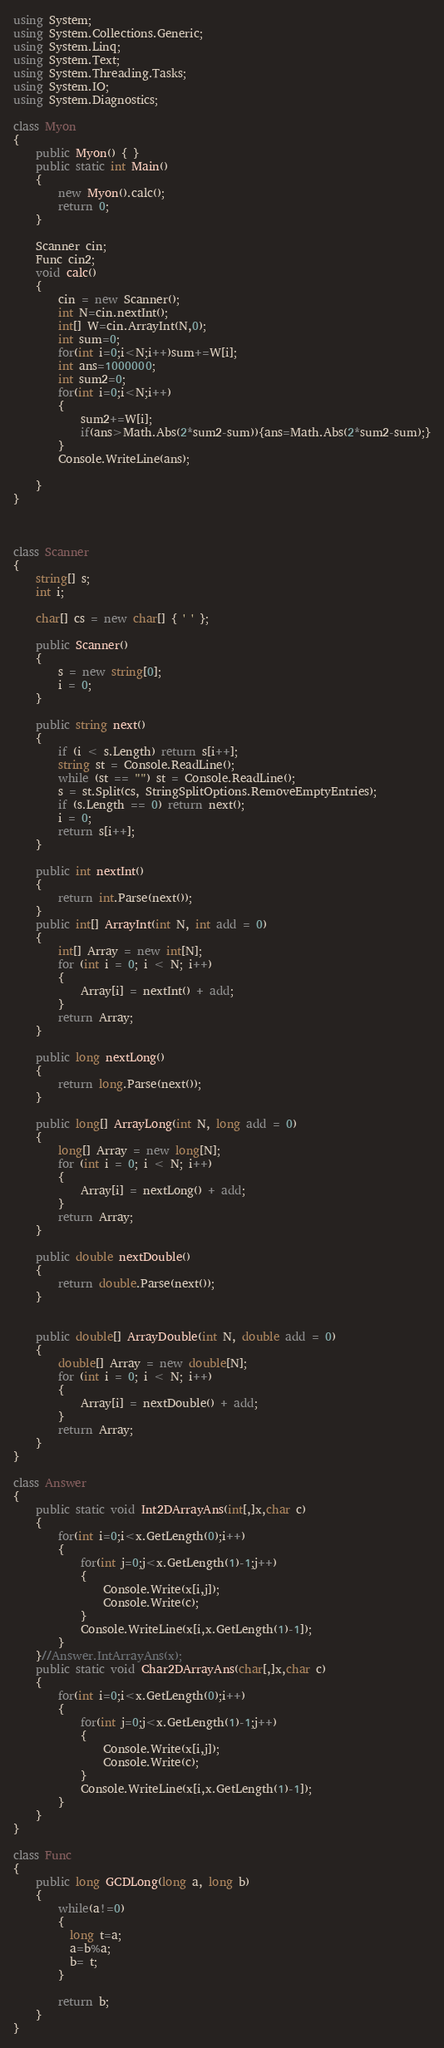<code> <loc_0><loc_0><loc_500><loc_500><_C#_>using System;
using System.Collections.Generic;
using System.Linq;
using System.Text;
using System.Threading.Tasks;
using System.IO;
using System.Diagnostics;

class Myon
{
    public Myon() { }
    public static int Main()
    {
        new Myon().calc();
        return 0;
    }

    Scanner cin;
    Func cin2;
    void calc()
    {
        cin = new Scanner();
        int N=cin.nextInt();
        int[] W=cin.ArrayInt(N,0);
        int sum=0;
        for(int i=0;i<N;i++)sum+=W[i];
        int ans=1000000;
        int sum2=0;
        for(int i=0;i<N;i++)
        {
            sum2+=W[i];
            if(ans>Math.Abs(2*sum2-sum)){ans=Math.Abs(2*sum2-sum);}
        }
        Console.WriteLine(ans);
        
    }
}



class Scanner
{
    string[] s;
    int i;

    char[] cs = new char[] { ' ' };

    public Scanner()
    {
        s = new string[0];
        i = 0;
    }

    public string next()
    {
        if (i < s.Length) return s[i++];
        string st = Console.ReadLine();
        while (st == "") st = Console.ReadLine();
        s = st.Split(cs, StringSplitOptions.RemoveEmptyEntries);
        if (s.Length == 0) return next();
        i = 0;
        return s[i++];
    }

    public int nextInt()
    {
        return int.Parse(next());
    }
    public int[] ArrayInt(int N, int add = 0)
    {
        int[] Array = new int[N];
        for (int i = 0; i < N; i++)
        {
            Array[i] = nextInt() + add;
        }
        return Array;
    }

    public long nextLong()
    {
        return long.Parse(next());
    }

    public long[] ArrayLong(int N, long add = 0)
    {
        long[] Array = new long[N];
        for (int i = 0; i < N; i++)
        {
            Array[i] = nextLong() + add;
        }
        return Array;
    }

    public double nextDouble()
    {
        return double.Parse(next());
    }


    public double[] ArrayDouble(int N, double add = 0)
    {
        double[] Array = new double[N];
        for (int i = 0; i < N; i++)
        {
            Array[i] = nextDouble() + add;
        }
        return Array;
    }
}

class Answer
{
    public static void Int2DArrayAns(int[,]x,char c)
    {
        for(int i=0;i<x.GetLength(0);i++)
        {
            for(int j=0;j<x.GetLength(1)-1;j++)
            {
                Console.Write(x[i,j]);
                Console.Write(c);
            }
            Console.WriteLine(x[i,x.GetLength(1)-1]);
        }
    }//Answer.IntArrayAns(x);
    public static void Char2DArrayAns(char[,]x,char c)
    {
        for(int i=0;i<x.GetLength(0);i++)
        {
            for(int j=0;j<x.GetLength(1)-1;j++)
            {
                Console.Write(x[i,j]);
                Console.Write(c);
            }
            Console.WriteLine(x[i,x.GetLength(1)-1]);
        }
    }
}

class Func
{
    public long GCDLong(long a, long b)
    {
        while(a!=0)
        {
          long t=a;
          a=b%a;
          b= t;
        }
      
        return b;        
    }
}
</code> 